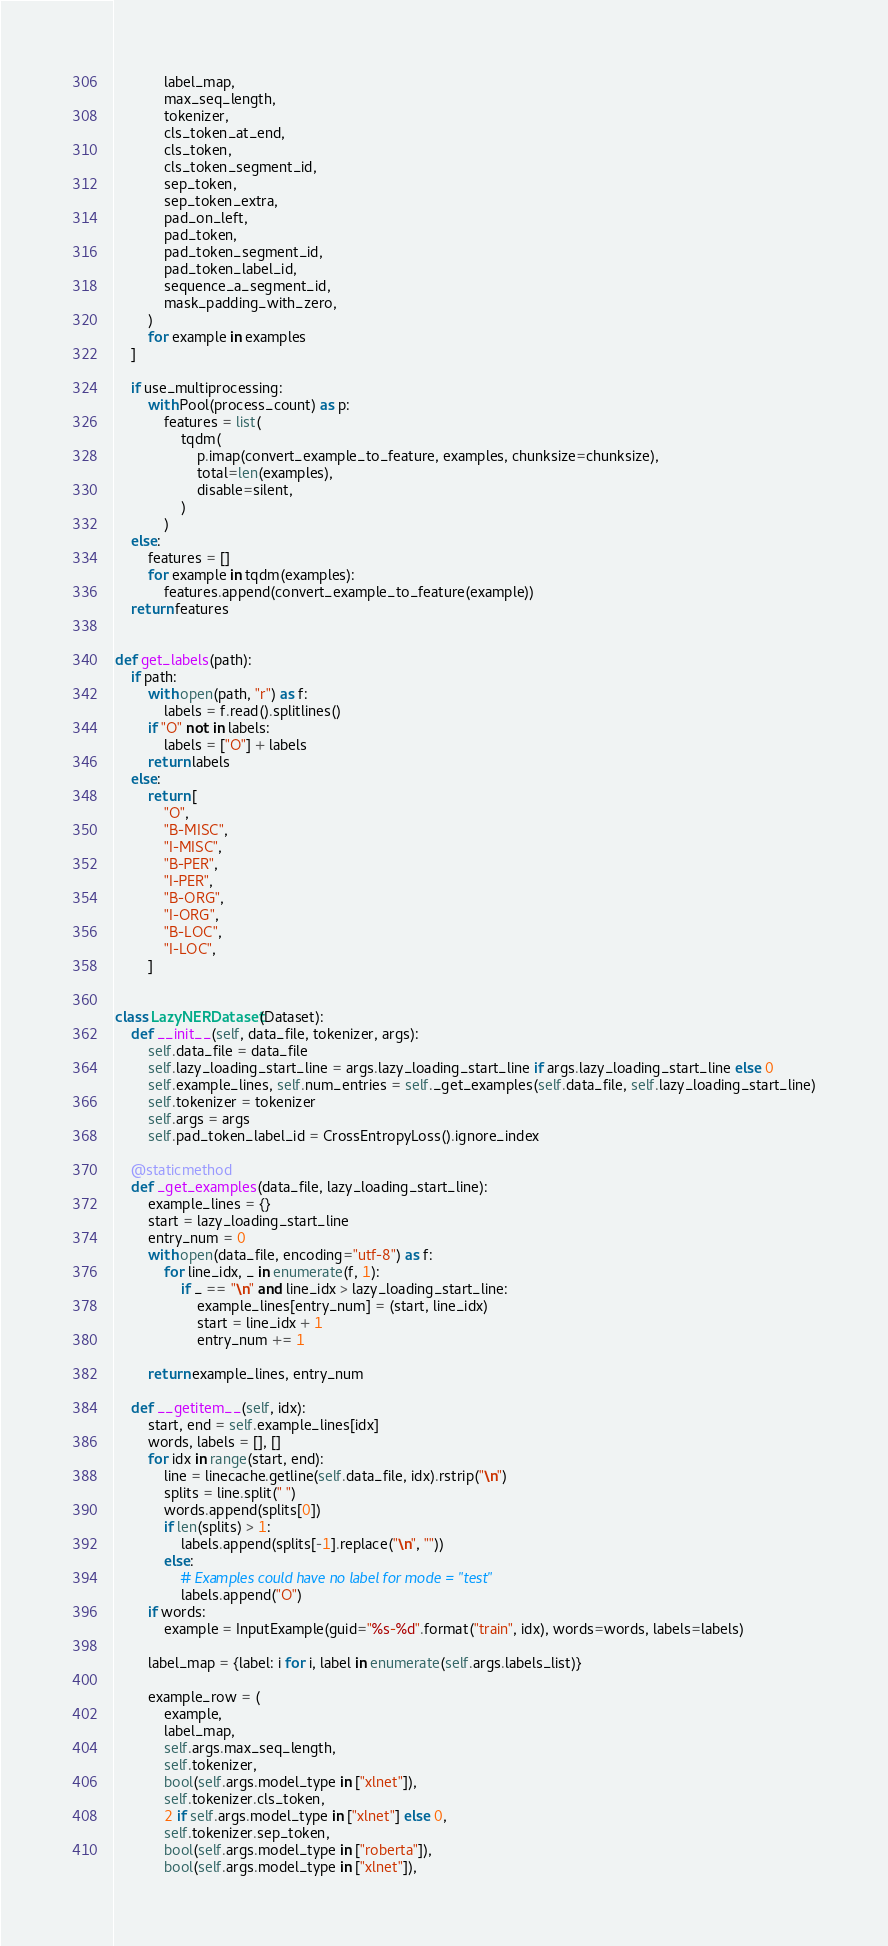<code> <loc_0><loc_0><loc_500><loc_500><_Python_>            label_map,
            max_seq_length,
            tokenizer,
            cls_token_at_end,
            cls_token,
            cls_token_segment_id,
            sep_token,
            sep_token_extra,
            pad_on_left,
            pad_token,
            pad_token_segment_id,
            pad_token_label_id,
            sequence_a_segment_id,
            mask_padding_with_zero,
        )
        for example in examples
    ]

    if use_multiprocessing:
        with Pool(process_count) as p:
            features = list(
                tqdm(
                    p.imap(convert_example_to_feature, examples, chunksize=chunksize),
                    total=len(examples),
                    disable=silent,
                )
            )
    else:
        features = []
        for example in tqdm(examples):
            features.append(convert_example_to_feature(example))
    return features


def get_labels(path):
    if path:
        with open(path, "r") as f:
            labels = f.read().splitlines()
        if "O" not in labels:
            labels = ["O"] + labels
        return labels
    else:
        return [
            "O",
            "B-MISC",
            "I-MISC",
            "B-PER",
            "I-PER",
            "B-ORG",
            "I-ORG",
            "B-LOC",
            "I-LOC",
        ]


class LazyNERDataset(Dataset):
    def __init__(self, data_file, tokenizer, args):
        self.data_file = data_file
        self.lazy_loading_start_line = args.lazy_loading_start_line if args.lazy_loading_start_line else 0
        self.example_lines, self.num_entries = self._get_examples(self.data_file, self.lazy_loading_start_line)
        self.tokenizer = tokenizer
        self.args = args
        self.pad_token_label_id = CrossEntropyLoss().ignore_index

    @staticmethod
    def _get_examples(data_file, lazy_loading_start_line):
        example_lines = {}
        start = lazy_loading_start_line
        entry_num = 0
        with open(data_file, encoding="utf-8") as f:
            for line_idx, _ in enumerate(f, 1):
                if _ == "\n" and line_idx > lazy_loading_start_line:
                    example_lines[entry_num] = (start, line_idx)
                    start = line_idx + 1
                    entry_num += 1

        return example_lines, entry_num

    def __getitem__(self, idx):
        start, end = self.example_lines[idx]
        words, labels = [], []
        for idx in range(start, end):
            line = linecache.getline(self.data_file, idx).rstrip("\n")
            splits = line.split(" ")
            words.append(splits[0])
            if len(splits) > 1:
                labels.append(splits[-1].replace("\n", ""))
            else:
                # Examples could have no label for mode = "test"
                labels.append("O")
        if words:
            example = InputExample(guid="%s-%d".format("train", idx), words=words, labels=labels)

        label_map = {label: i for i, label in enumerate(self.args.labels_list)}

        example_row = (
            example,
            label_map,
            self.args.max_seq_length,
            self.tokenizer,
            bool(self.args.model_type in ["xlnet"]),
            self.tokenizer.cls_token,
            2 if self.args.model_type in ["xlnet"] else 0,
            self.tokenizer.sep_token,
            bool(self.args.model_type in ["roberta"]),
            bool(self.args.model_type in ["xlnet"]),</code> 